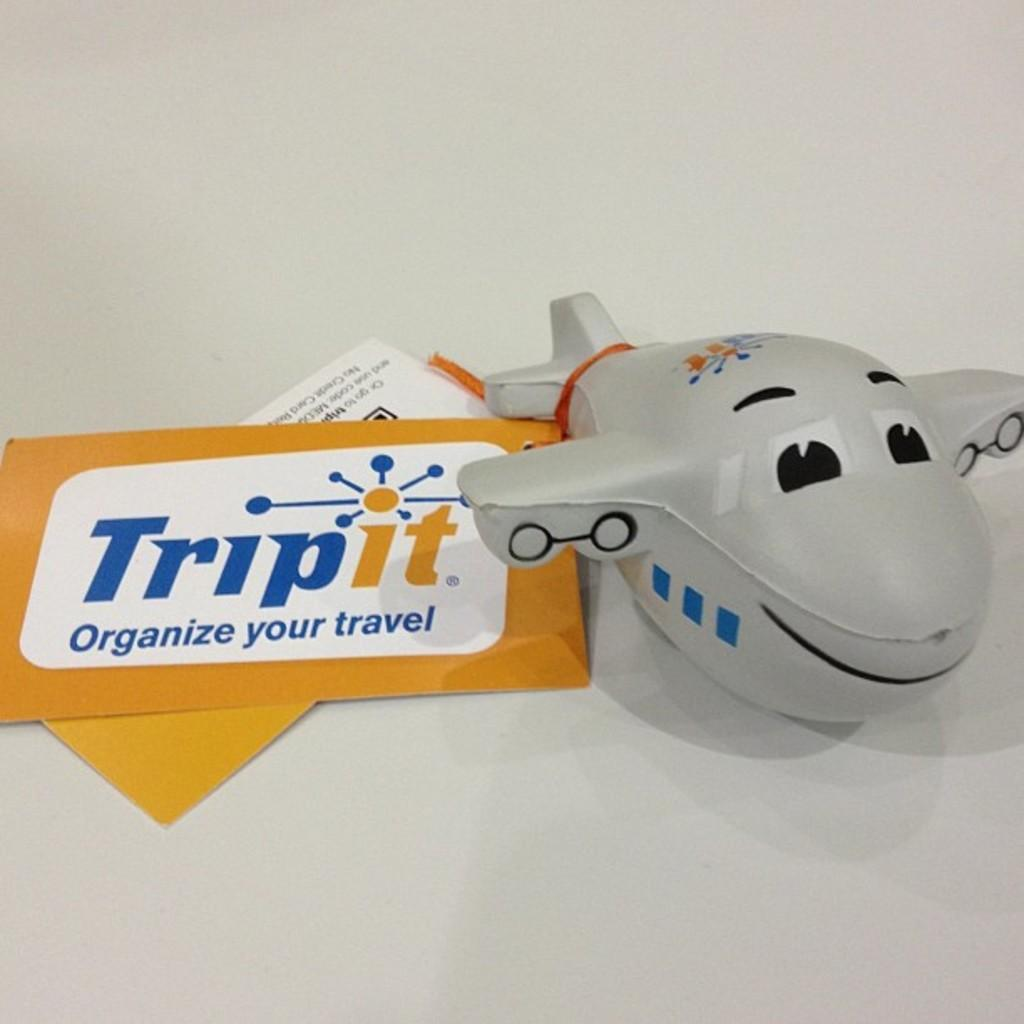<image>
Present a compact description of the photo's key features. Plane squeeze toy from Tripit Organize your travel 